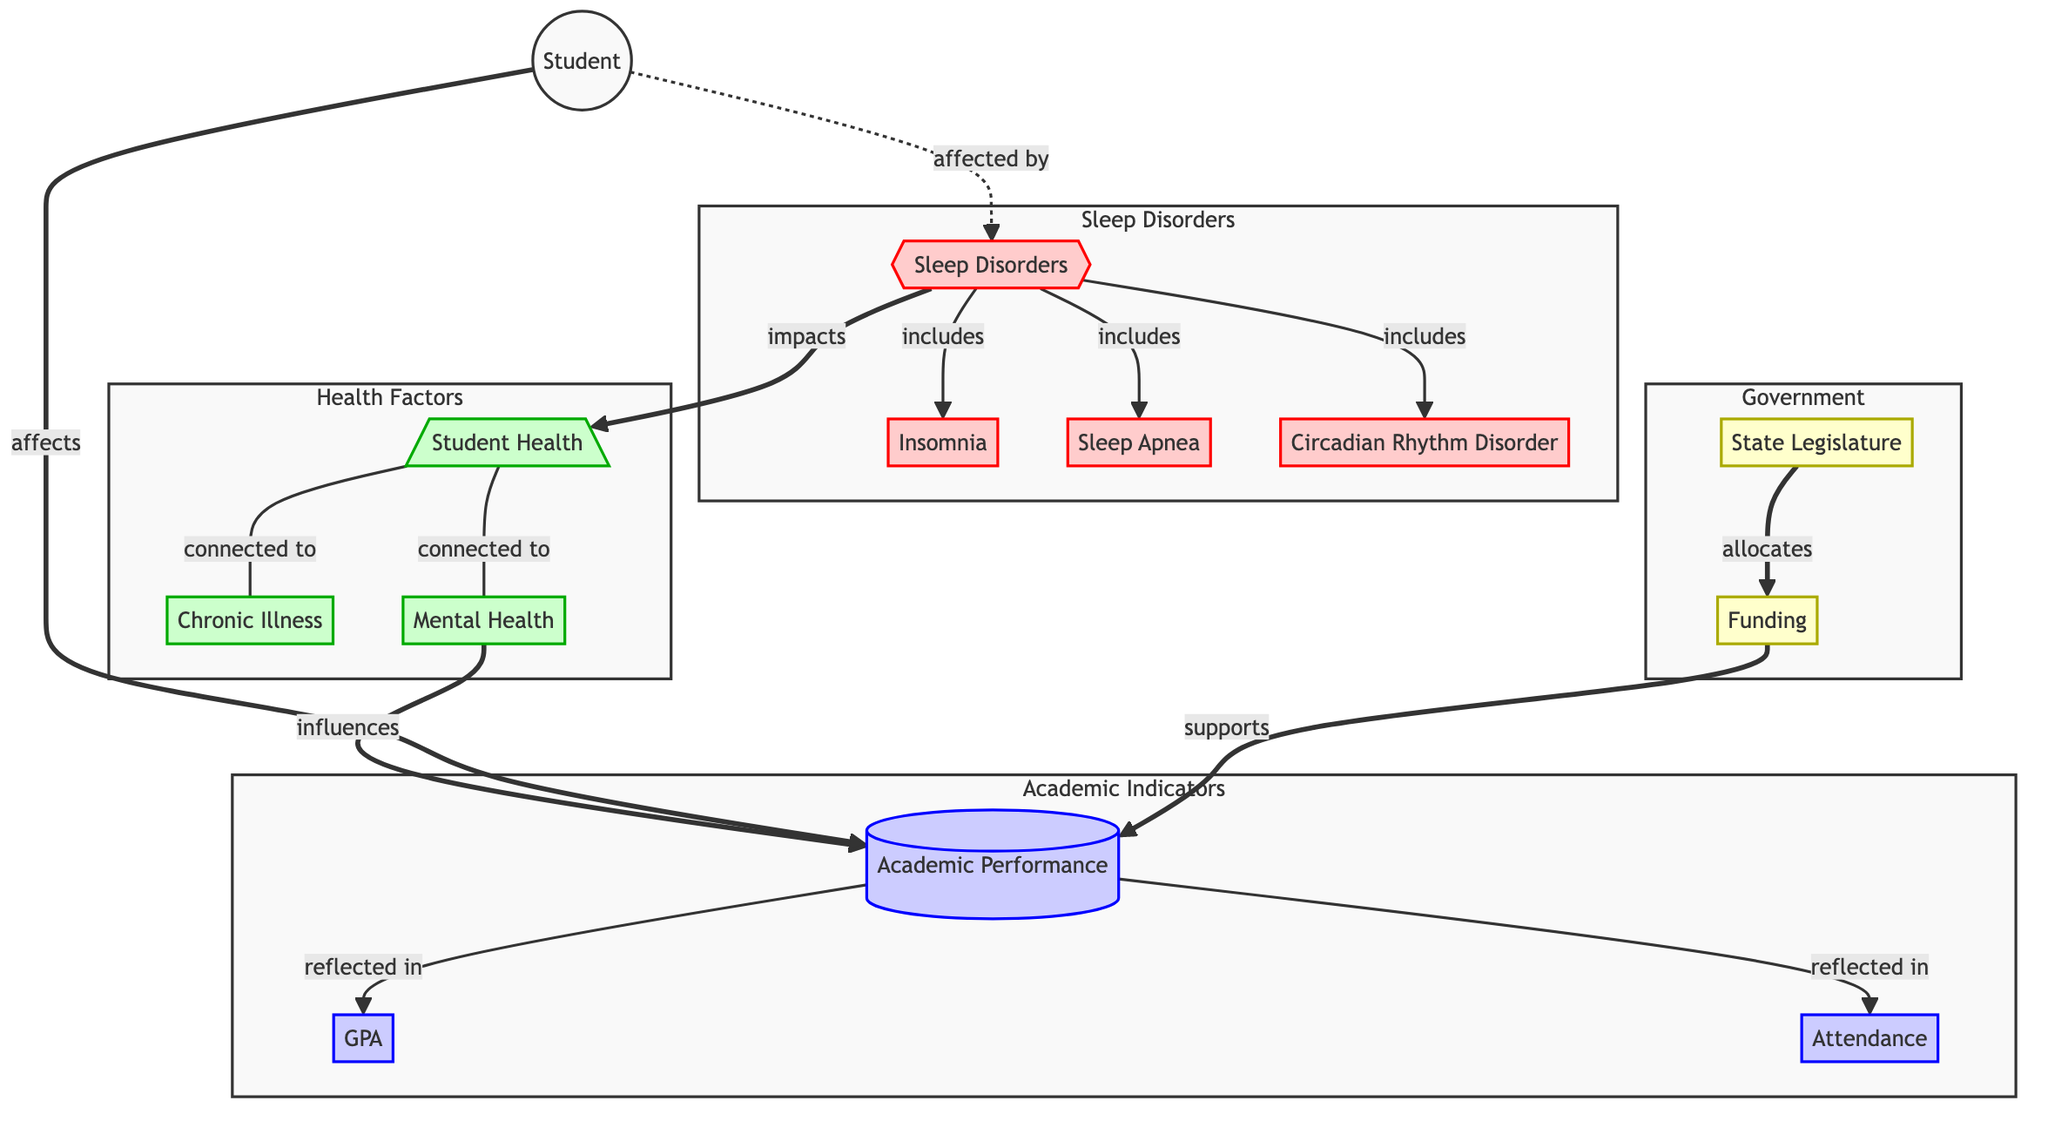What are the three types of sleep disorders mentioned? The diagram lists three specific types of sleep disorders: Insomnia, Sleep Apnea, and Circadian Rhythm Disorder, which are directly depicted as nodes under the "Sleep Disorders" category.
Answer: Insomnia, Sleep Apnea, Circadian Rhythm Disorder Which node is impacted by sleep disorders? The diagram shows that "Sleep Disorders" impacts "Student Health," indicating a direct relationship between the two nodes.
Answer: Student Health How does student health influence academic performance? The flowchart illustrates that "Mental Health," which is connected to "Student Health," influences "Academic Performance." This indicates an indirect connection through mental health.
Answer: Mental Health What are the two academic performance indicators reflected in the diagram? According to the diagram, the two academic performance indicators are "GPA" and "Attendance," which are reflected in the "Academic Performance" node.
Answer: GPA, Attendance How does the state legislature's funding support academic performance? The diagram illustrates that "State Legislature" allocates "Funding," which directly supports "Academic Performance," showing a flow of resources from government to education.
Answer: Academic Performance What is the connection between student health and chronic illness? The diagram explicitly depicts a direct link between "Student Health" and "Chronic Illness," indicating they are interconnected factors in the context of health.
Answer: Chronic Illness Which entity allocates funding? The diagram clearly identifies the "State Legislature" as the entity that allocates funding, indicating its role in the educational financing process.
Answer: State Legislature What is the role of chronic illness in the diagram? "Chronic Illness" is connected to "Student Health" in the diagram, suggesting it is a contributing factor to overall student health issues as represented in the flowchart.
Answer: Contributing factor How many nodes are present in the "Health Factors" subgraph? The "Health Factors" subgraph contains three nodes: "Student Health," "Chronic Illness," and "Mental Health." Hence, the count of nodes is three.
Answer: Three 